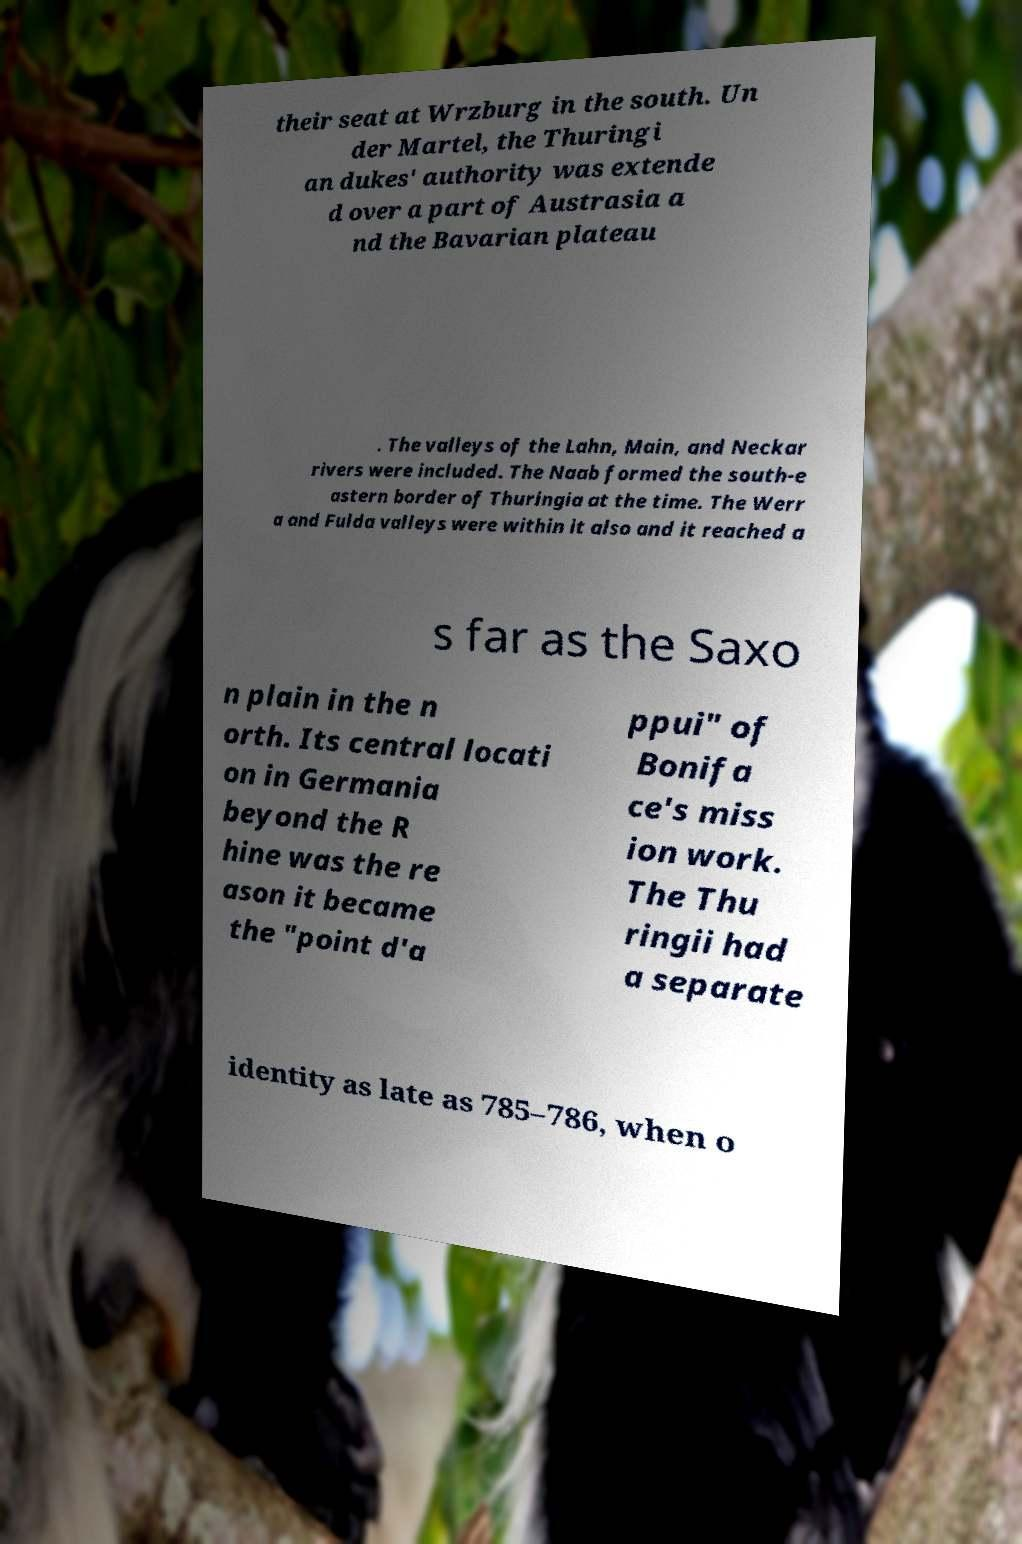There's text embedded in this image that I need extracted. Can you transcribe it verbatim? their seat at Wrzburg in the south. Un der Martel, the Thuringi an dukes' authority was extende d over a part of Austrasia a nd the Bavarian plateau . The valleys of the Lahn, Main, and Neckar rivers were included. The Naab formed the south-e astern border of Thuringia at the time. The Werr a and Fulda valleys were within it also and it reached a s far as the Saxo n plain in the n orth. Its central locati on in Germania beyond the R hine was the re ason it became the "point d'a ppui" of Bonifa ce's miss ion work. The Thu ringii had a separate identity as late as 785–786, when o 